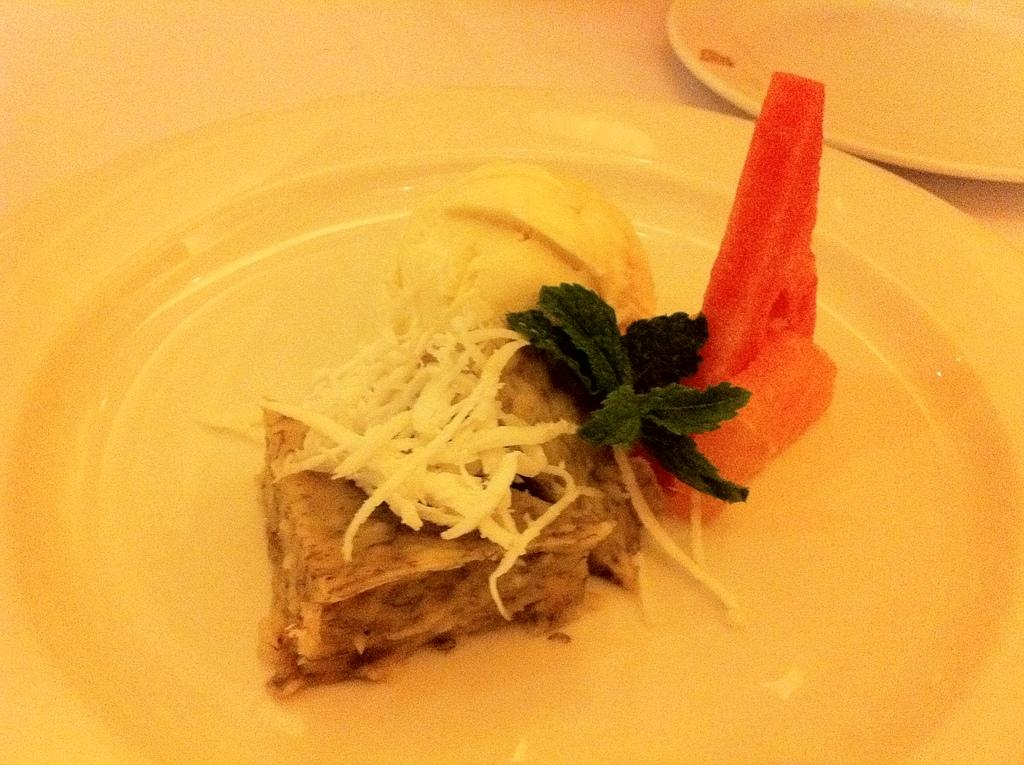What type of bread is visible in the image? There is a bread with white cheese spread on it in the image. What other food items can be seen in the image? There is mango ice cream and watermelon in the image. How are the food items arranged in the image? The food items are placed on a white plate. What type of music is playing in the background of the image? There is no music playing in the background of the image; it only shows food items on a plate. 